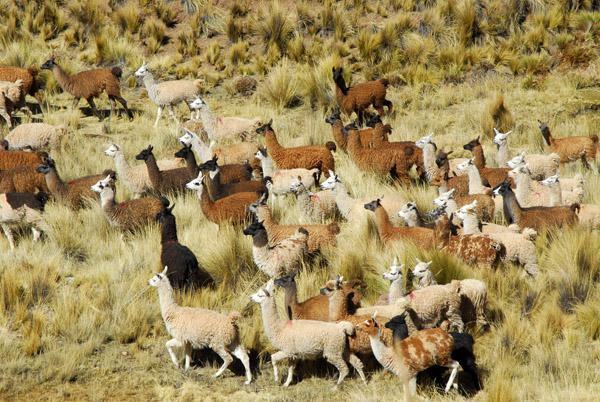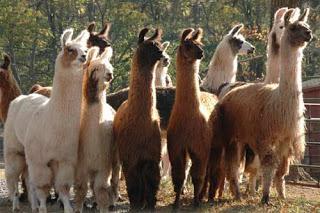The first image is the image on the left, the second image is the image on the right. Examine the images to the left and right. Is the description "One image shows at least ten llamas standing in place with their heads upright and angled rightward." accurate? Answer yes or no. Yes. 